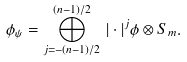<formula> <loc_0><loc_0><loc_500><loc_500>\phi _ { \psi } = \bigoplus _ { j = - ( n - 1 ) / 2 } ^ { ( n - 1 ) / 2 } \, | \cdot | ^ { j } \phi \otimes S _ { m } .</formula> 